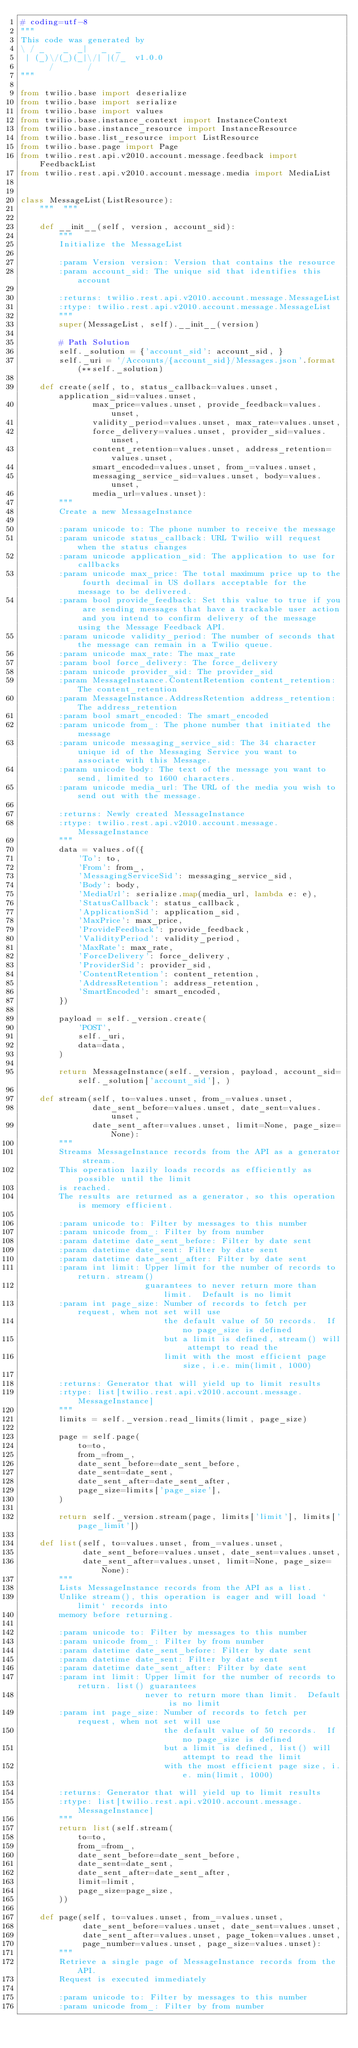<code> <loc_0><loc_0><loc_500><loc_500><_Python_># coding=utf-8
"""
This code was generated by
\ / _    _  _|   _  _
 | (_)\/(_)(_|\/| |(/_  v1.0.0
      /       /
"""

from twilio.base import deserialize
from twilio.base import serialize
from twilio.base import values
from twilio.base.instance_context import InstanceContext
from twilio.base.instance_resource import InstanceResource
from twilio.base.list_resource import ListResource
from twilio.base.page import Page
from twilio.rest.api.v2010.account.message.feedback import FeedbackList
from twilio.rest.api.v2010.account.message.media import MediaList


class MessageList(ListResource):
    """  """

    def __init__(self, version, account_sid):
        """
        Initialize the MessageList

        :param Version version: Version that contains the resource
        :param account_sid: The unique sid that identifies this account

        :returns: twilio.rest.api.v2010.account.message.MessageList
        :rtype: twilio.rest.api.v2010.account.message.MessageList
        """
        super(MessageList, self).__init__(version)

        # Path Solution
        self._solution = {'account_sid': account_sid, }
        self._uri = '/Accounts/{account_sid}/Messages.json'.format(**self._solution)

    def create(self, to, status_callback=values.unset, application_sid=values.unset,
               max_price=values.unset, provide_feedback=values.unset,
               validity_period=values.unset, max_rate=values.unset,
               force_delivery=values.unset, provider_sid=values.unset,
               content_retention=values.unset, address_retention=values.unset,
               smart_encoded=values.unset, from_=values.unset,
               messaging_service_sid=values.unset, body=values.unset,
               media_url=values.unset):
        """
        Create a new MessageInstance

        :param unicode to: The phone number to receive the message
        :param unicode status_callback: URL Twilio will request when the status changes
        :param unicode application_sid: The application to use for callbacks
        :param unicode max_price: The total maximum price up to the fourth decimal in US dollars acceptable for the message to be delivered.
        :param bool provide_feedback: Set this value to true if you are sending messages that have a trackable user action and you intend to confirm delivery of the message using the Message Feedback API.
        :param unicode validity_period: The number of seconds that the message can remain in a Twilio queue.
        :param unicode max_rate: The max_rate
        :param bool force_delivery: The force_delivery
        :param unicode provider_sid: The provider_sid
        :param MessageInstance.ContentRetention content_retention: The content_retention
        :param MessageInstance.AddressRetention address_retention: The address_retention
        :param bool smart_encoded: The smart_encoded
        :param unicode from_: The phone number that initiated the message
        :param unicode messaging_service_sid: The 34 character unique id of the Messaging Service you want to associate with this Message.
        :param unicode body: The text of the message you want to send, limited to 1600 characters.
        :param unicode media_url: The URL of the media you wish to send out with the message.

        :returns: Newly created MessageInstance
        :rtype: twilio.rest.api.v2010.account.message.MessageInstance
        """
        data = values.of({
            'To': to,
            'From': from_,
            'MessagingServiceSid': messaging_service_sid,
            'Body': body,
            'MediaUrl': serialize.map(media_url, lambda e: e),
            'StatusCallback': status_callback,
            'ApplicationSid': application_sid,
            'MaxPrice': max_price,
            'ProvideFeedback': provide_feedback,
            'ValidityPeriod': validity_period,
            'MaxRate': max_rate,
            'ForceDelivery': force_delivery,
            'ProviderSid': provider_sid,
            'ContentRetention': content_retention,
            'AddressRetention': address_retention,
            'SmartEncoded': smart_encoded,
        })

        payload = self._version.create(
            'POST',
            self._uri,
            data=data,
        )

        return MessageInstance(self._version, payload, account_sid=self._solution['account_sid'], )

    def stream(self, to=values.unset, from_=values.unset,
               date_sent_before=values.unset, date_sent=values.unset,
               date_sent_after=values.unset, limit=None, page_size=None):
        """
        Streams MessageInstance records from the API as a generator stream.
        This operation lazily loads records as efficiently as possible until the limit
        is reached.
        The results are returned as a generator, so this operation is memory efficient.

        :param unicode to: Filter by messages to this number
        :param unicode from_: Filter by from number
        :param datetime date_sent_before: Filter by date sent
        :param datetime date_sent: Filter by date sent
        :param datetime date_sent_after: Filter by date sent
        :param int limit: Upper limit for the number of records to return. stream()
                          guarantees to never return more than limit.  Default is no limit
        :param int page_size: Number of records to fetch per request, when not set will use
                              the default value of 50 records.  If no page_size is defined
                              but a limit is defined, stream() will attempt to read the
                              limit with the most efficient page size, i.e. min(limit, 1000)

        :returns: Generator that will yield up to limit results
        :rtype: list[twilio.rest.api.v2010.account.message.MessageInstance]
        """
        limits = self._version.read_limits(limit, page_size)

        page = self.page(
            to=to,
            from_=from_,
            date_sent_before=date_sent_before,
            date_sent=date_sent,
            date_sent_after=date_sent_after,
            page_size=limits['page_size'],
        )

        return self._version.stream(page, limits['limit'], limits['page_limit'])

    def list(self, to=values.unset, from_=values.unset,
             date_sent_before=values.unset, date_sent=values.unset,
             date_sent_after=values.unset, limit=None, page_size=None):
        """
        Lists MessageInstance records from the API as a list.
        Unlike stream(), this operation is eager and will load `limit` records into
        memory before returning.

        :param unicode to: Filter by messages to this number
        :param unicode from_: Filter by from number
        :param datetime date_sent_before: Filter by date sent
        :param datetime date_sent: Filter by date sent
        :param datetime date_sent_after: Filter by date sent
        :param int limit: Upper limit for the number of records to return. list() guarantees
                          never to return more than limit.  Default is no limit
        :param int page_size: Number of records to fetch per request, when not set will use
                              the default value of 50 records.  If no page_size is defined
                              but a limit is defined, list() will attempt to read the limit
                              with the most efficient page size, i.e. min(limit, 1000)

        :returns: Generator that will yield up to limit results
        :rtype: list[twilio.rest.api.v2010.account.message.MessageInstance]
        """
        return list(self.stream(
            to=to,
            from_=from_,
            date_sent_before=date_sent_before,
            date_sent=date_sent,
            date_sent_after=date_sent_after,
            limit=limit,
            page_size=page_size,
        ))

    def page(self, to=values.unset, from_=values.unset,
             date_sent_before=values.unset, date_sent=values.unset,
             date_sent_after=values.unset, page_token=values.unset,
             page_number=values.unset, page_size=values.unset):
        """
        Retrieve a single page of MessageInstance records from the API.
        Request is executed immediately

        :param unicode to: Filter by messages to this number
        :param unicode from_: Filter by from number</code> 